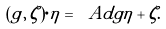<formula> <loc_0><loc_0><loc_500><loc_500>( g , \, \zeta ) \cdot \eta = \ A d g \eta + \zeta .</formula> 